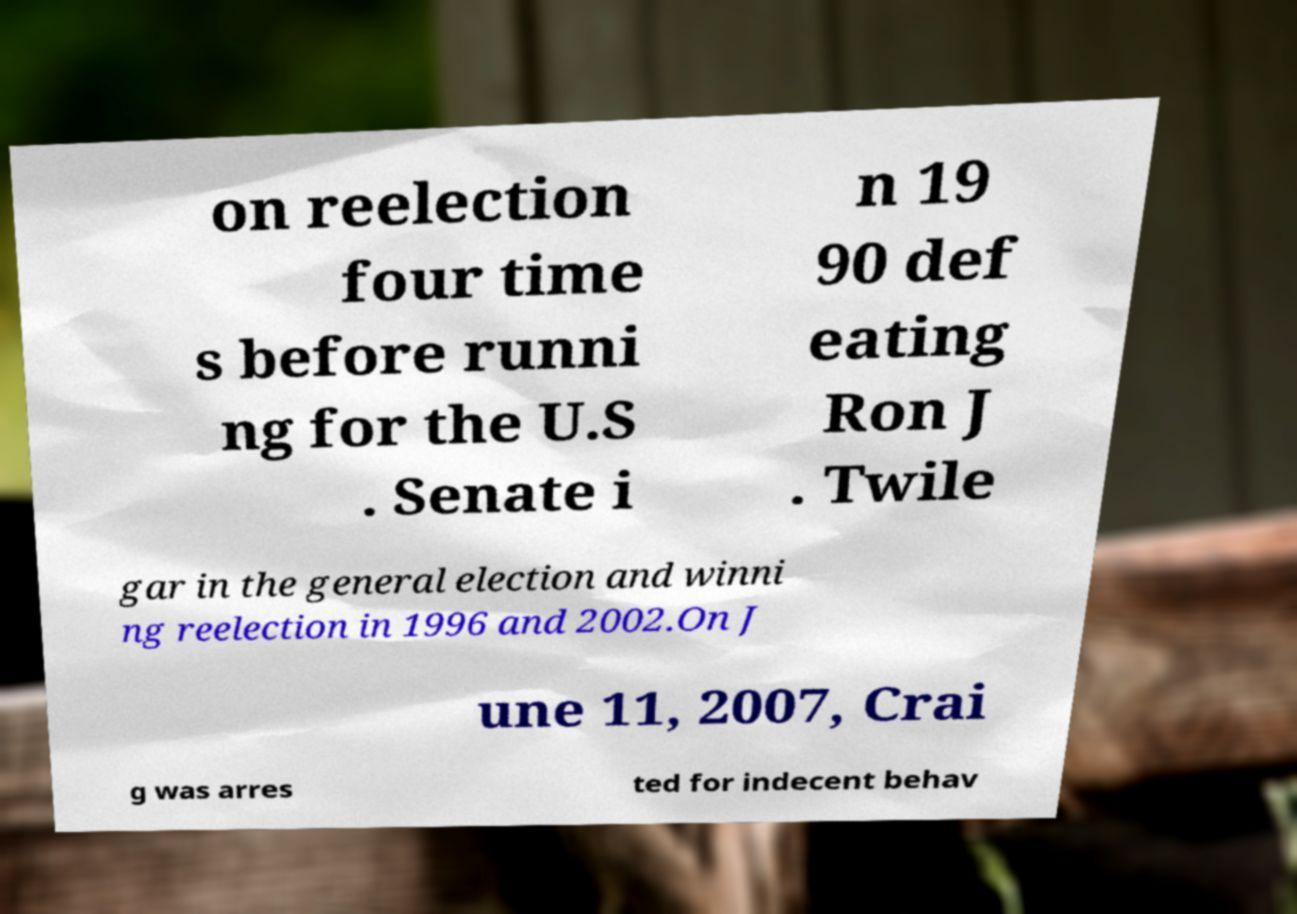Please identify and transcribe the text found in this image. on reelection four time s before runni ng for the U.S . Senate i n 19 90 def eating Ron J . Twile gar in the general election and winni ng reelection in 1996 and 2002.On J une 11, 2007, Crai g was arres ted for indecent behav 